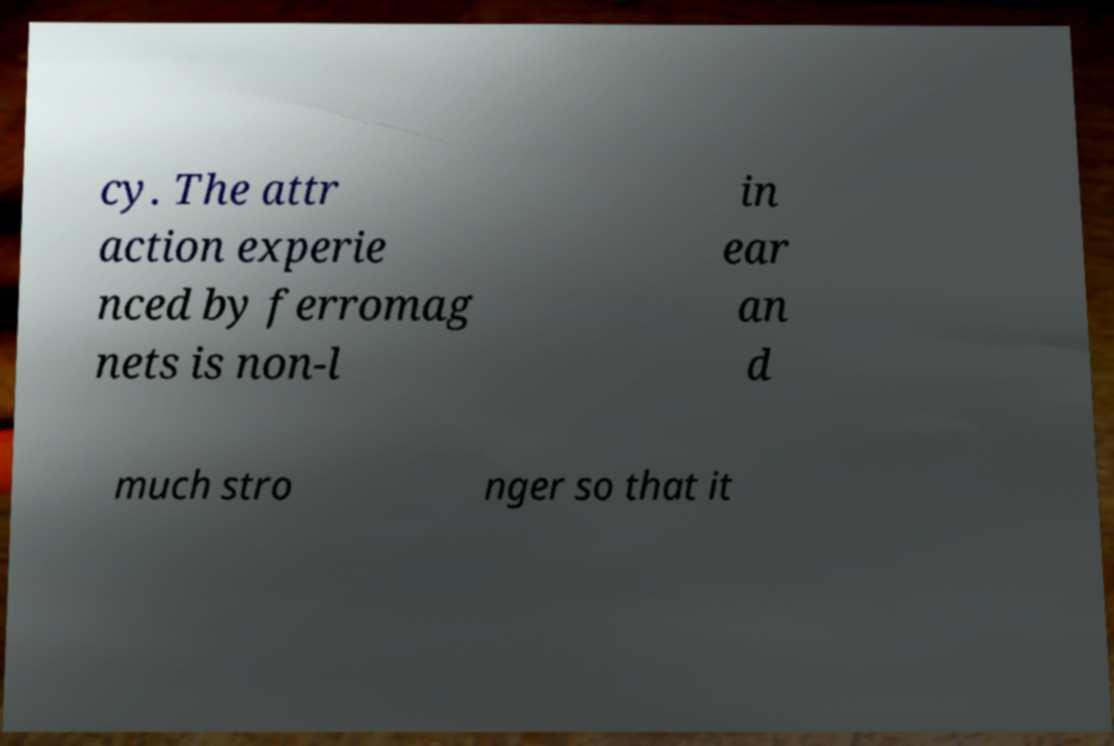Can you read and provide the text displayed in the image?This photo seems to have some interesting text. Can you extract and type it out for me? cy. The attr action experie nced by ferromag nets is non-l in ear an d much stro nger so that it 